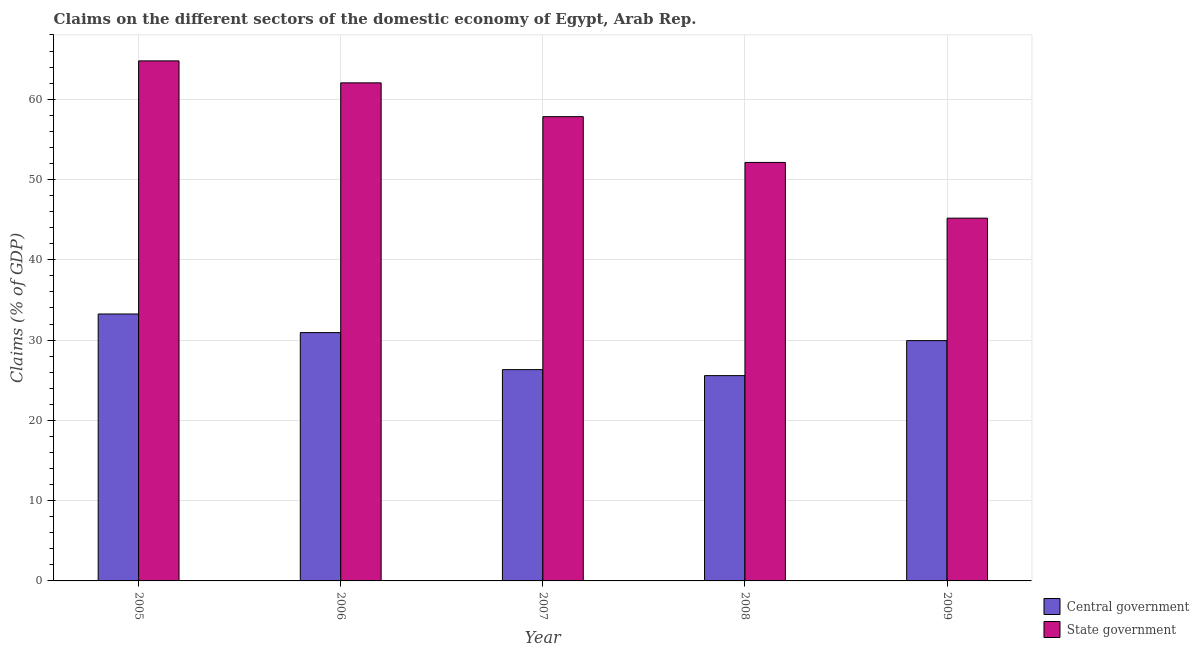How many different coloured bars are there?
Give a very brief answer. 2. How many groups of bars are there?
Offer a terse response. 5. Are the number of bars per tick equal to the number of legend labels?
Offer a very short reply. Yes. Are the number of bars on each tick of the X-axis equal?
Offer a very short reply. Yes. How many bars are there on the 5th tick from the left?
Offer a very short reply. 2. What is the label of the 1st group of bars from the left?
Your answer should be very brief. 2005. What is the claims on state government in 2007?
Keep it short and to the point. 57.83. Across all years, what is the maximum claims on state government?
Make the answer very short. 64.77. Across all years, what is the minimum claims on state government?
Ensure brevity in your answer.  45.18. In which year was the claims on state government maximum?
Make the answer very short. 2005. What is the total claims on central government in the graph?
Make the answer very short. 146. What is the difference between the claims on state government in 2005 and that in 2006?
Keep it short and to the point. 2.74. What is the difference between the claims on central government in 2008 and the claims on state government in 2007?
Your response must be concise. -0.75. What is the average claims on central government per year?
Provide a succinct answer. 29.2. What is the ratio of the claims on state government in 2006 to that in 2007?
Provide a short and direct response. 1.07. Is the difference between the claims on central government in 2005 and 2009 greater than the difference between the claims on state government in 2005 and 2009?
Ensure brevity in your answer.  No. What is the difference between the highest and the second highest claims on central government?
Keep it short and to the point. 2.32. What is the difference between the highest and the lowest claims on central government?
Provide a short and direct response. 7.67. Is the sum of the claims on central government in 2005 and 2009 greater than the maximum claims on state government across all years?
Keep it short and to the point. Yes. What does the 1st bar from the left in 2005 represents?
Keep it short and to the point. Central government. What does the 1st bar from the right in 2009 represents?
Provide a short and direct response. State government. How many bars are there?
Provide a succinct answer. 10. Are all the bars in the graph horizontal?
Offer a terse response. No. How many years are there in the graph?
Keep it short and to the point. 5. What is the difference between two consecutive major ticks on the Y-axis?
Your answer should be compact. 10. Where does the legend appear in the graph?
Provide a succinct answer. Bottom right. How many legend labels are there?
Your response must be concise. 2. What is the title of the graph?
Offer a very short reply. Claims on the different sectors of the domestic economy of Egypt, Arab Rep. What is the label or title of the Y-axis?
Keep it short and to the point. Claims (% of GDP). What is the Claims (% of GDP) in Central government in 2005?
Provide a short and direct response. 33.25. What is the Claims (% of GDP) of State government in 2005?
Provide a short and direct response. 64.77. What is the Claims (% of GDP) of Central government in 2006?
Give a very brief answer. 30.93. What is the Claims (% of GDP) in State government in 2006?
Keep it short and to the point. 62.04. What is the Claims (% of GDP) of Central government in 2007?
Your response must be concise. 26.32. What is the Claims (% of GDP) of State government in 2007?
Offer a very short reply. 57.83. What is the Claims (% of GDP) of Central government in 2008?
Offer a terse response. 25.57. What is the Claims (% of GDP) of State government in 2008?
Provide a succinct answer. 52.13. What is the Claims (% of GDP) in Central government in 2009?
Ensure brevity in your answer.  29.93. What is the Claims (% of GDP) of State government in 2009?
Keep it short and to the point. 45.18. Across all years, what is the maximum Claims (% of GDP) in Central government?
Your response must be concise. 33.25. Across all years, what is the maximum Claims (% of GDP) of State government?
Provide a short and direct response. 64.77. Across all years, what is the minimum Claims (% of GDP) in Central government?
Offer a very short reply. 25.57. Across all years, what is the minimum Claims (% of GDP) in State government?
Keep it short and to the point. 45.18. What is the total Claims (% of GDP) in Central government in the graph?
Give a very brief answer. 146. What is the total Claims (% of GDP) in State government in the graph?
Your answer should be compact. 281.95. What is the difference between the Claims (% of GDP) in Central government in 2005 and that in 2006?
Your answer should be very brief. 2.32. What is the difference between the Claims (% of GDP) of State government in 2005 and that in 2006?
Keep it short and to the point. 2.74. What is the difference between the Claims (% of GDP) of Central government in 2005 and that in 2007?
Provide a succinct answer. 6.93. What is the difference between the Claims (% of GDP) of State government in 2005 and that in 2007?
Offer a terse response. 6.95. What is the difference between the Claims (% of GDP) in Central government in 2005 and that in 2008?
Your answer should be very brief. 7.67. What is the difference between the Claims (% of GDP) in State government in 2005 and that in 2008?
Provide a short and direct response. 12.65. What is the difference between the Claims (% of GDP) of Central government in 2005 and that in 2009?
Make the answer very short. 3.32. What is the difference between the Claims (% of GDP) of State government in 2005 and that in 2009?
Offer a terse response. 19.59. What is the difference between the Claims (% of GDP) in Central government in 2006 and that in 2007?
Keep it short and to the point. 4.61. What is the difference between the Claims (% of GDP) in State government in 2006 and that in 2007?
Keep it short and to the point. 4.21. What is the difference between the Claims (% of GDP) of Central government in 2006 and that in 2008?
Offer a very short reply. 5.36. What is the difference between the Claims (% of GDP) in State government in 2006 and that in 2008?
Offer a terse response. 9.91. What is the difference between the Claims (% of GDP) of State government in 2006 and that in 2009?
Ensure brevity in your answer.  16.85. What is the difference between the Claims (% of GDP) of Central government in 2007 and that in 2008?
Your answer should be compact. 0.75. What is the difference between the Claims (% of GDP) in State government in 2007 and that in 2008?
Your response must be concise. 5.7. What is the difference between the Claims (% of GDP) of Central government in 2007 and that in 2009?
Your answer should be very brief. -3.61. What is the difference between the Claims (% of GDP) of State government in 2007 and that in 2009?
Your answer should be compact. 12.64. What is the difference between the Claims (% of GDP) of Central government in 2008 and that in 2009?
Provide a short and direct response. -4.36. What is the difference between the Claims (% of GDP) of State government in 2008 and that in 2009?
Provide a succinct answer. 6.94. What is the difference between the Claims (% of GDP) in Central government in 2005 and the Claims (% of GDP) in State government in 2006?
Offer a very short reply. -28.79. What is the difference between the Claims (% of GDP) of Central government in 2005 and the Claims (% of GDP) of State government in 2007?
Provide a short and direct response. -24.58. What is the difference between the Claims (% of GDP) of Central government in 2005 and the Claims (% of GDP) of State government in 2008?
Ensure brevity in your answer.  -18.88. What is the difference between the Claims (% of GDP) of Central government in 2005 and the Claims (% of GDP) of State government in 2009?
Offer a terse response. -11.94. What is the difference between the Claims (% of GDP) in Central government in 2006 and the Claims (% of GDP) in State government in 2007?
Make the answer very short. -26.9. What is the difference between the Claims (% of GDP) in Central government in 2006 and the Claims (% of GDP) in State government in 2008?
Provide a succinct answer. -21.2. What is the difference between the Claims (% of GDP) of Central government in 2006 and the Claims (% of GDP) of State government in 2009?
Your answer should be very brief. -14.25. What is the difference between the Claims (% of GDP) of Central government in 2007 and the Claims (% of GDP) of State government in 2008?
Provide a short and direct response. -25.81. What is the difference between the Claims (% of GDP) in Central government in 2007 and the Claims (% of GDP) in State government in 2009?
Make the answer very short. -18.86. What is the difference between the Claims (% of GDP) of Central government in 2008 and the Claims (% of GDP) of State government in 2009?
Give a very brief answer. -19.61. What is the average Claims (% of GDP) of Central government per year?
Your response must be concise. 29.2. What is the average Claims (% of GDP) in State government per year?
Provide a short and direct response. 56.39. In the year 2005, what is the difference between the Claims (% of GDP) in Central government and Claims (% of GDP) in State government?
Provide a succinct answer. -31.53. In the year 2006, what is the difference between the Claims (% of GDP) of Central government and Claims (% of GDP) of State government?
Your answer should be compact. -31.11. In the year 2007, what is the difference between the Claims (% of GDP) in Central government and Claims (% of GDP) in State government?
Make the answer very short. -31.51. In the year 2008, what is the difference between the Claims (% of GDP) of Central government and Claims (% of GDP) of State government?
Offer a terse response. -26.55. In the year 2009, what is the difference between the Claims (% of GDP) of Central government and Claims (% of GDP) of State government?
Give a very brief answer. -15.25. What is the ratio of the Claims (% of GDP) of Central government in 2005 to that in 2006?
Give a very brief answer. 1.07. What is the ratio of the Claims (% of GDP) in State government in 2005 to that in 2006?
Make the answer very short. 1.04. What is the ratio of the Claims (% of GDP) of Central government in 2005 to that in 2007?
Keep it short and to the point. 1.26. What is the ratio of the Claims (% of GDP) of State government in 2005 to that in 2007?
Offer a terse response. 1.12. What is the ratio of the Claims (% of GDP) in Central government in 2005 to that in 2008?
Keep it short and to the point. 1.3. What is the ratio of the Claims (% of GDP) of State government in 2005 to that in 2008?
Ensure brevity in your answer.  1.24. What is the ratio of the Claims (% of GDP) of Central government in 2005 to that in 2009?
Offer a terse response. 1.11. What is the ratio of the Claims (% of GDP) in State government in 2005 to that in 2009?
Offer a very short reply. 1.43. What is the ratio of the Claims (% of GDP) of Central government in 2006 to that in 2007?
Give a very brief answer. 1.18. What is the ratio of the Claims (% of GDP) of State government in 2006 to that in 2007?
Offer a terse response. 1.07. What is the ratio of the Claims (% of GDP) in Central government in 2006 to that in 2008?
Your answer should be compact. 1.21. What is the ratio of the Claims (% of GDP) of State government in 2006 to that in 2008?
Give a very brief answer. 1.19. What is the ratio of the Claims (% of GDP) in Central government in 2006 to that in 2009?
Provide a short and direct response. 1.03. What is the ratio of the Claims (% of GDP) of State government in 2006 to that in 2009?
Provide a succinct answer. 1.37. What is the ratio of the Claims (% of GDP) in Central government in 2007 to that in 2008?
Ensure brevity in your answer.  1.03. What is the ratio of the Claims (% of GDP) in State government in 2007 to that in 2008?
Ensure brevity in your answer.  1.11. What is the ratio of the Claims (% of GDP) in Central government in 2007 to that in 2009?
Give a very brief answer. 0.88. What is the ratio of the Claims (% of GDP) in State government in 2007 to that in 2009?
Your answer should be compact. 1.28. What is the ratio of the Claims (% of GDP) of Central government in 2008 to that in 2009?
Your answer should be compact. 0.85. What is the ratio of the Claims (% of GDP) of State government in 2008 to that in 2009?
Provide a succinct answer. 1.15. What is the difference between the highest and the second highest Claims (% of GDP) in Central government?
Provide a short and direct response. 2.32. What is the difference between the highest and the second highest Claims (% of GDP) in State government?
Provide a short and direct response. 2.74. What is the difference between the highest and the lowest Claims (% of GDP) in Central government?
Make the answer very short. 7.67. What is the difference between the highest and the lowest Claims (% of GDP) of State government?
Keep it short and to the point. 19.59. 